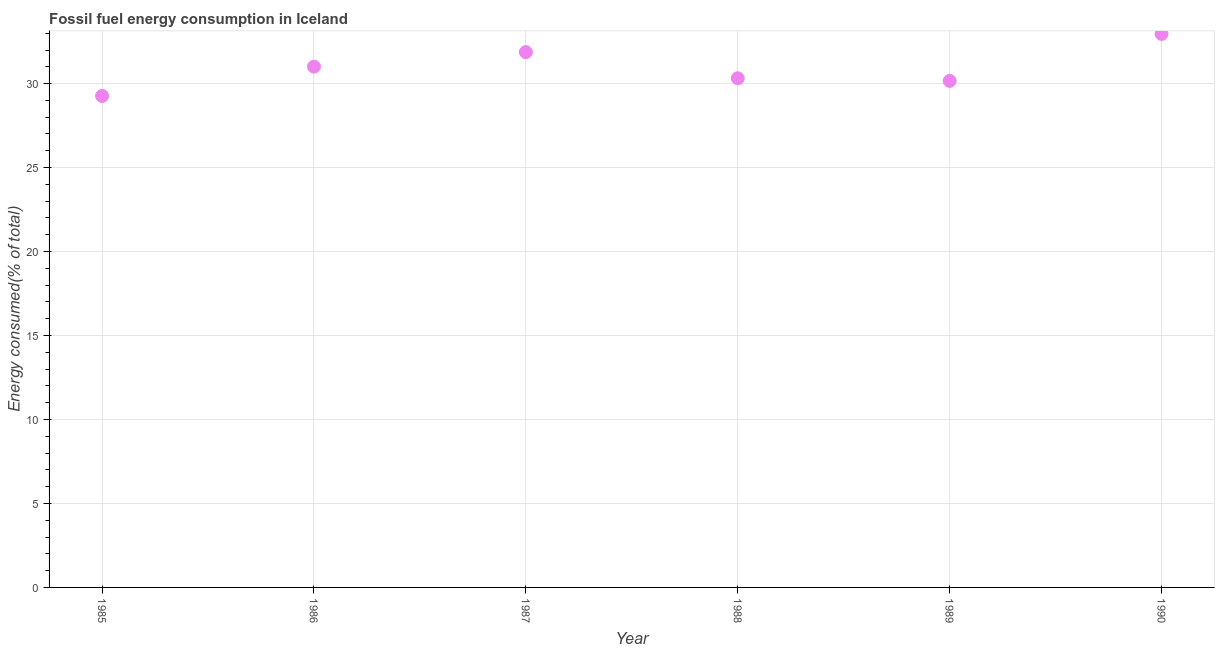What is the fossil fuel energy consumption in 1988?
Your answer should be compact. 30.32. Across all years, what is the maximum fossil fuel energy consumption?
Your response must be concise. 32.96. Across all years, what is the minimum fossil fuel energy consumption?
Provide a short and direct response. 29.27. In which year was the fossil fuel energy consumption maximum?
Make the answer very short. 1990. In which year was the fossil fuel energy consumption minimum?
Keep it short and to the point. 1985. What is the sum of the fossil fuel energy consumption?
Your answer should be compact. 185.59. What is the difference between the fossil fuel energy consumption in 1987 and 1988?
Your response must be concise. 1.56. What is the average fossil fuel energy consumption per year?
Provide a short and direct response. 30.93. What is the median fossil fuel energy consumption?
Keep it short and to the point. 30.66. In how many years, is the fossil fuel energy consumption greater than 23 %?
Give a very brief answer. 6. What is the ratio of the fossil fuel energy consumption in 1987 to that in 1990?
Make the answer very short. 0.97. What is the difference between the highest and the second highest fossil fuel energy consumption?
Your answer should be very brief. 1.08. Is the sum of the fossil fuel energy consumption in 1985 and 1990 greater than the maximum fossil fuel energy consumption across all years?
Give a very brief answer. Yes. What is the difference between the highest and the lowest fossil fuel energy consumption?
Make the answer very short. 3.69. Does the fossil fuel energy consumption monotonically increase over the years?
Keep it short and to the point. No. What is the title of the graph?
Your answer should be compact. Fossil fuel energy consumption in Iceland. What is the label or title of the X-axis?
Your answer should be very brief. Year. What is the label or title of the Y-axis?
Offer a terse response. Energy consumed(% of total). What is the Energy consumed(% of total) in 1985?
Keep it short and to the point. 29.27. What is the Energy consumed(% of total) in 1986?
Provide a short and direct response. 31.01. What is the Energy consumed(% of total) in 1987?
Keep it short and to the point. 31.87. What is the Energy consumed(% of total) in 1988?
Offer a terse response. 30.32. What is the Energy consumed(% of total) in 1989?
Your response must be concise. 30.16. What is the Energy consumed(% of total) in 1990?
Your answer should be compact. 32.96. What is the difference between the Energy consumed(% of total) in 1985 and 1986?
Your response must be concise. -1.74. What is the difference between the Energy consumed(% of total) in 1985 and 1987?
Make the answer very short. -2.61. What is the difference between the Energy consumed(% of total) in 1985 and 1988?
Offer a terse response. -1.05. What is the difference between the Energy consumed(% of total) in 1985 and 1989?
Provide a succinct answer. -0.89. What is the difference between the Energy consumed(% of total) in 1985 and 1990?
Provide a short and direct response. -3.69. What is the difference between the Energy consumed(% of total) in 1986 and 1987?
Provide a short and direct response. -0.86. What is the difference between the Energy consumed(% of total) in 1986 and 1988?
Provide a succinct answer. 0.69. What is the difference between the Energy consumed(% of total) in 1986 and 1989?
Make the answer very short. 0.85. What is the difference between the Energy consumed(% of total) in 1986 and 1990?
Your answer should be very brief. -1.95. What is the difference between the Energy consumed(% of total) in 1987 and 1988?
Provide a short and direct response. 1.56. What is the difference between the Energy consumed(% of total) in 1987 and 1989?
Provide a short and direct response. 1.71. What is the difference between the Energy consumed(% of total) in 1987 and 1990?
Keep it short and to the point. -1.08. What is the difference between the Energy consumed(% of total) in 1988 and 1989?
Ensure brevity in your answer.  0.16. What is the difference between the Energy consumed(% of total) in 1988 and 1990?
Keep it short and to the point. -2.64. What is the difference between the Energy consumed(% of total) in 1989 and 1990?
Ensure brevity in your answer.  -2.8. What is the ratio of the Energy consumed(% of total) in 1985 to that in 1986?
Give a very brief answer. 0.94. What is the ratio of the Energy consumed(% of total) in 1985 to that in 1987?
Provide a succinct answer. 0.92. What is the ratio of the Energy consumed(% of total) in 1985 to that in 1989?
Make the answer very short. 0.97. What is the ratio of the Energy consumed(% of total) in 1985 to that in 1990?
Your response must be concise. 0.89. What is the ratio of the Energy consumed(% of total) in 1986 to that in 1987?
Keep it short and to the point. 0.97. What is the ratio of the Energy consumed(% of total) in 1986 to that in 1989?
Ensure brevity in your answer.  1.03. What is the ratio of the Energy consumed(% of total) in 1986 to that in 1990?
Give a very brief answer. 0.94. What is the ratio of the Energy consumed(% of total) in 1987 to that in 1988?
Offer a terse response. 1.05. What is the ratio of the Energy consumed(% of total) in 1987 to that in 1989?
Your answer should be compact. 1.06. What is the ratio of the Energy consumed(% of total) in 1989 to that in 1990?
Ensure brevity in your answer.  0.92. 